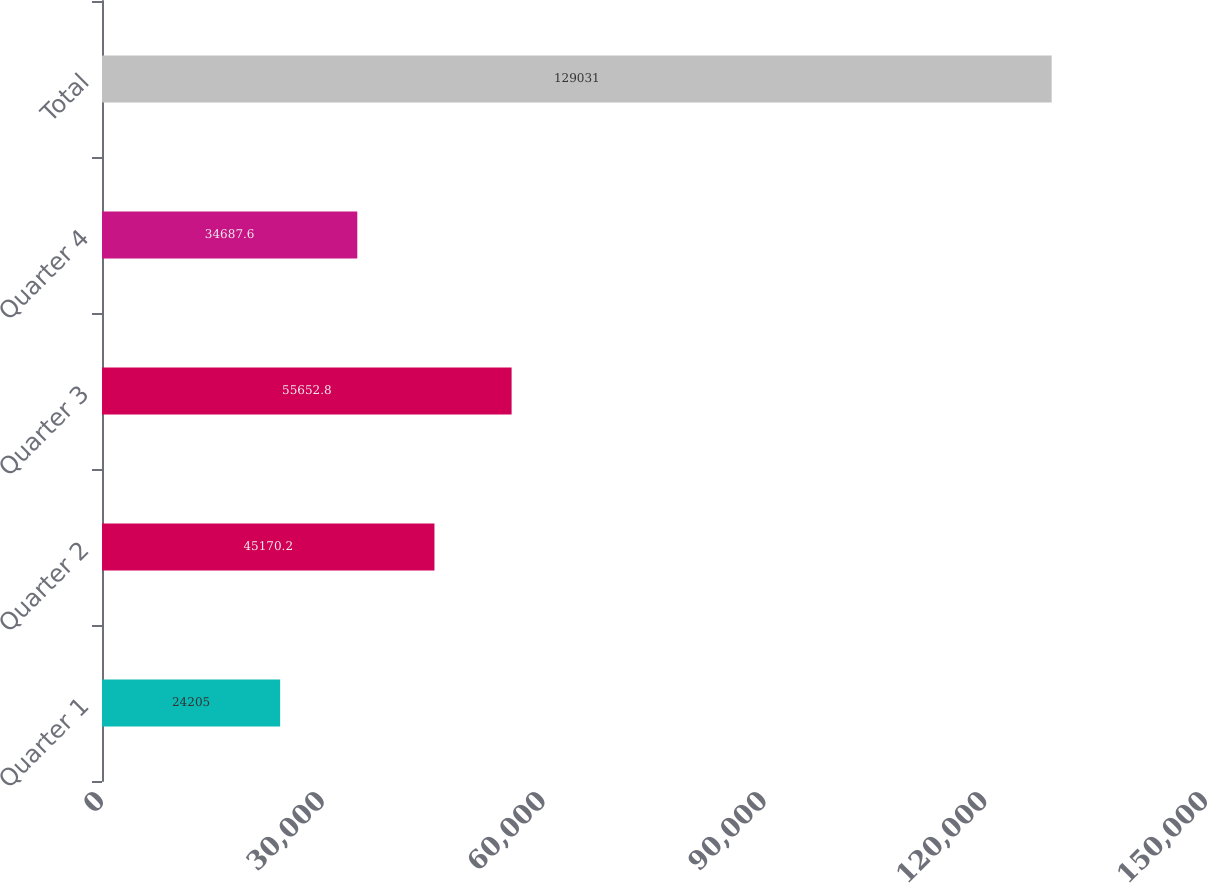Convert chart to OTSL. <chart><loc_0><loc_0><loc_500><loc_500><bar_chart><fcel>Quarter 1<fcel>Quarter 2<fcel>Quarter 3<fcel>Quarter 4<fcel>Total<nl><fcel>24205<fcel>45170.2<fcel>55652.8<fcel>34687.6<fcel>129031<nl></chart> 